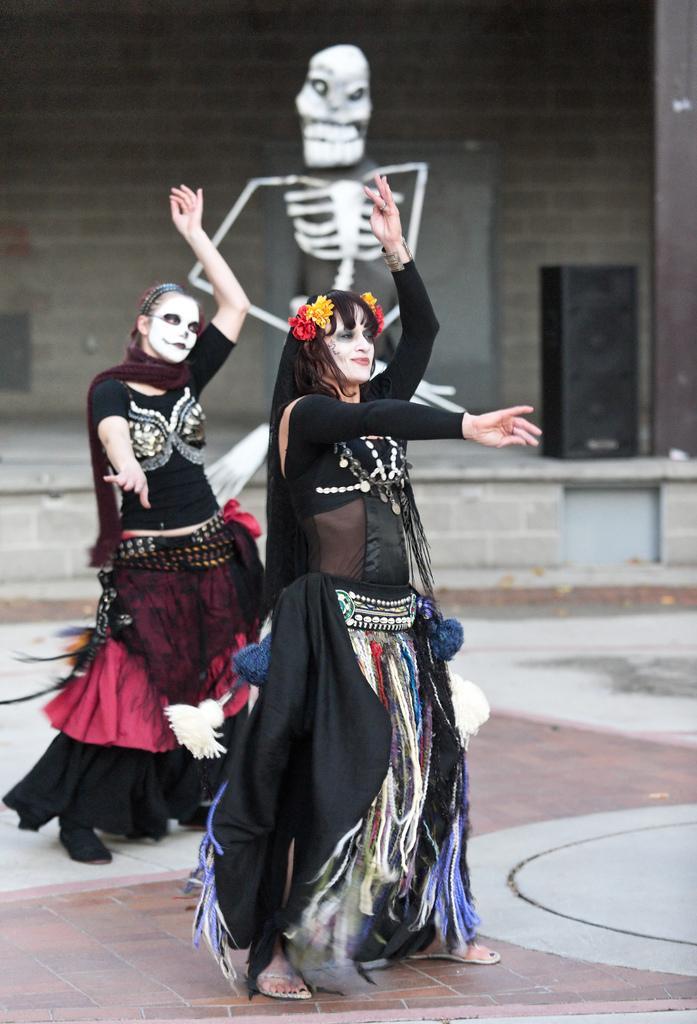Describe this image in one or two sentences. In this image, there are two persons wearing clothes and dancing on the floor in front of the wall. There is a skeleton in the middle of the image. There is a speaker on the right side of the image. 